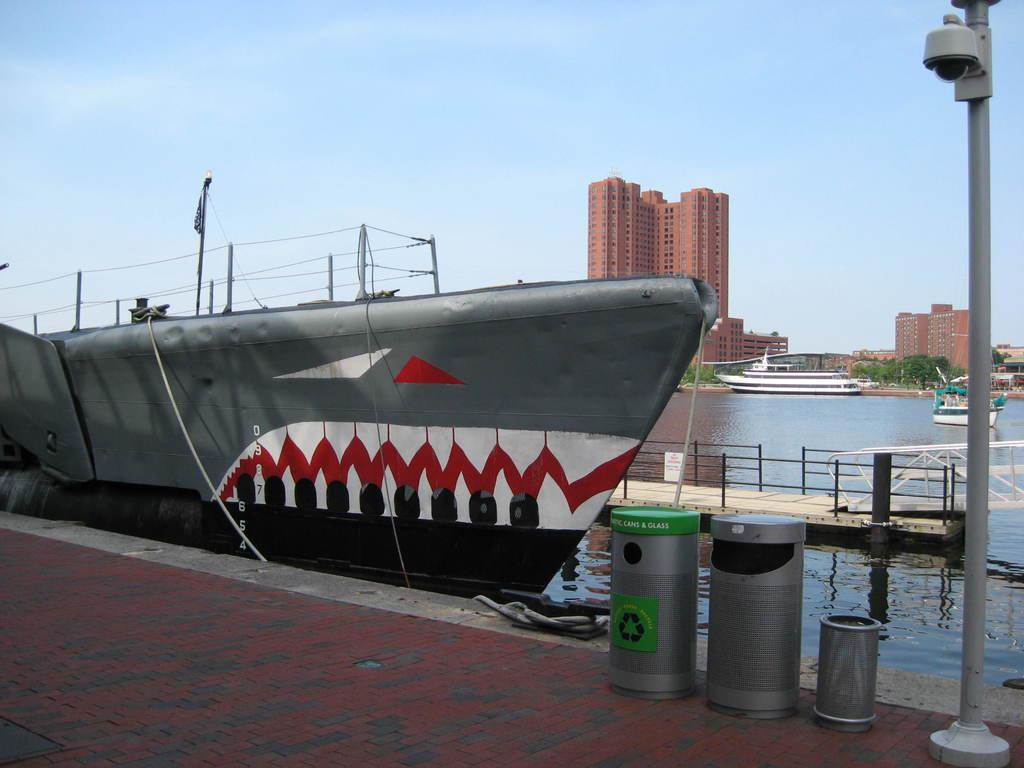<image>
Provide a brief description of the given image. A submarine with a shark face painted on it is docked next to a Can and Glass recycling bin and two trash cans. 